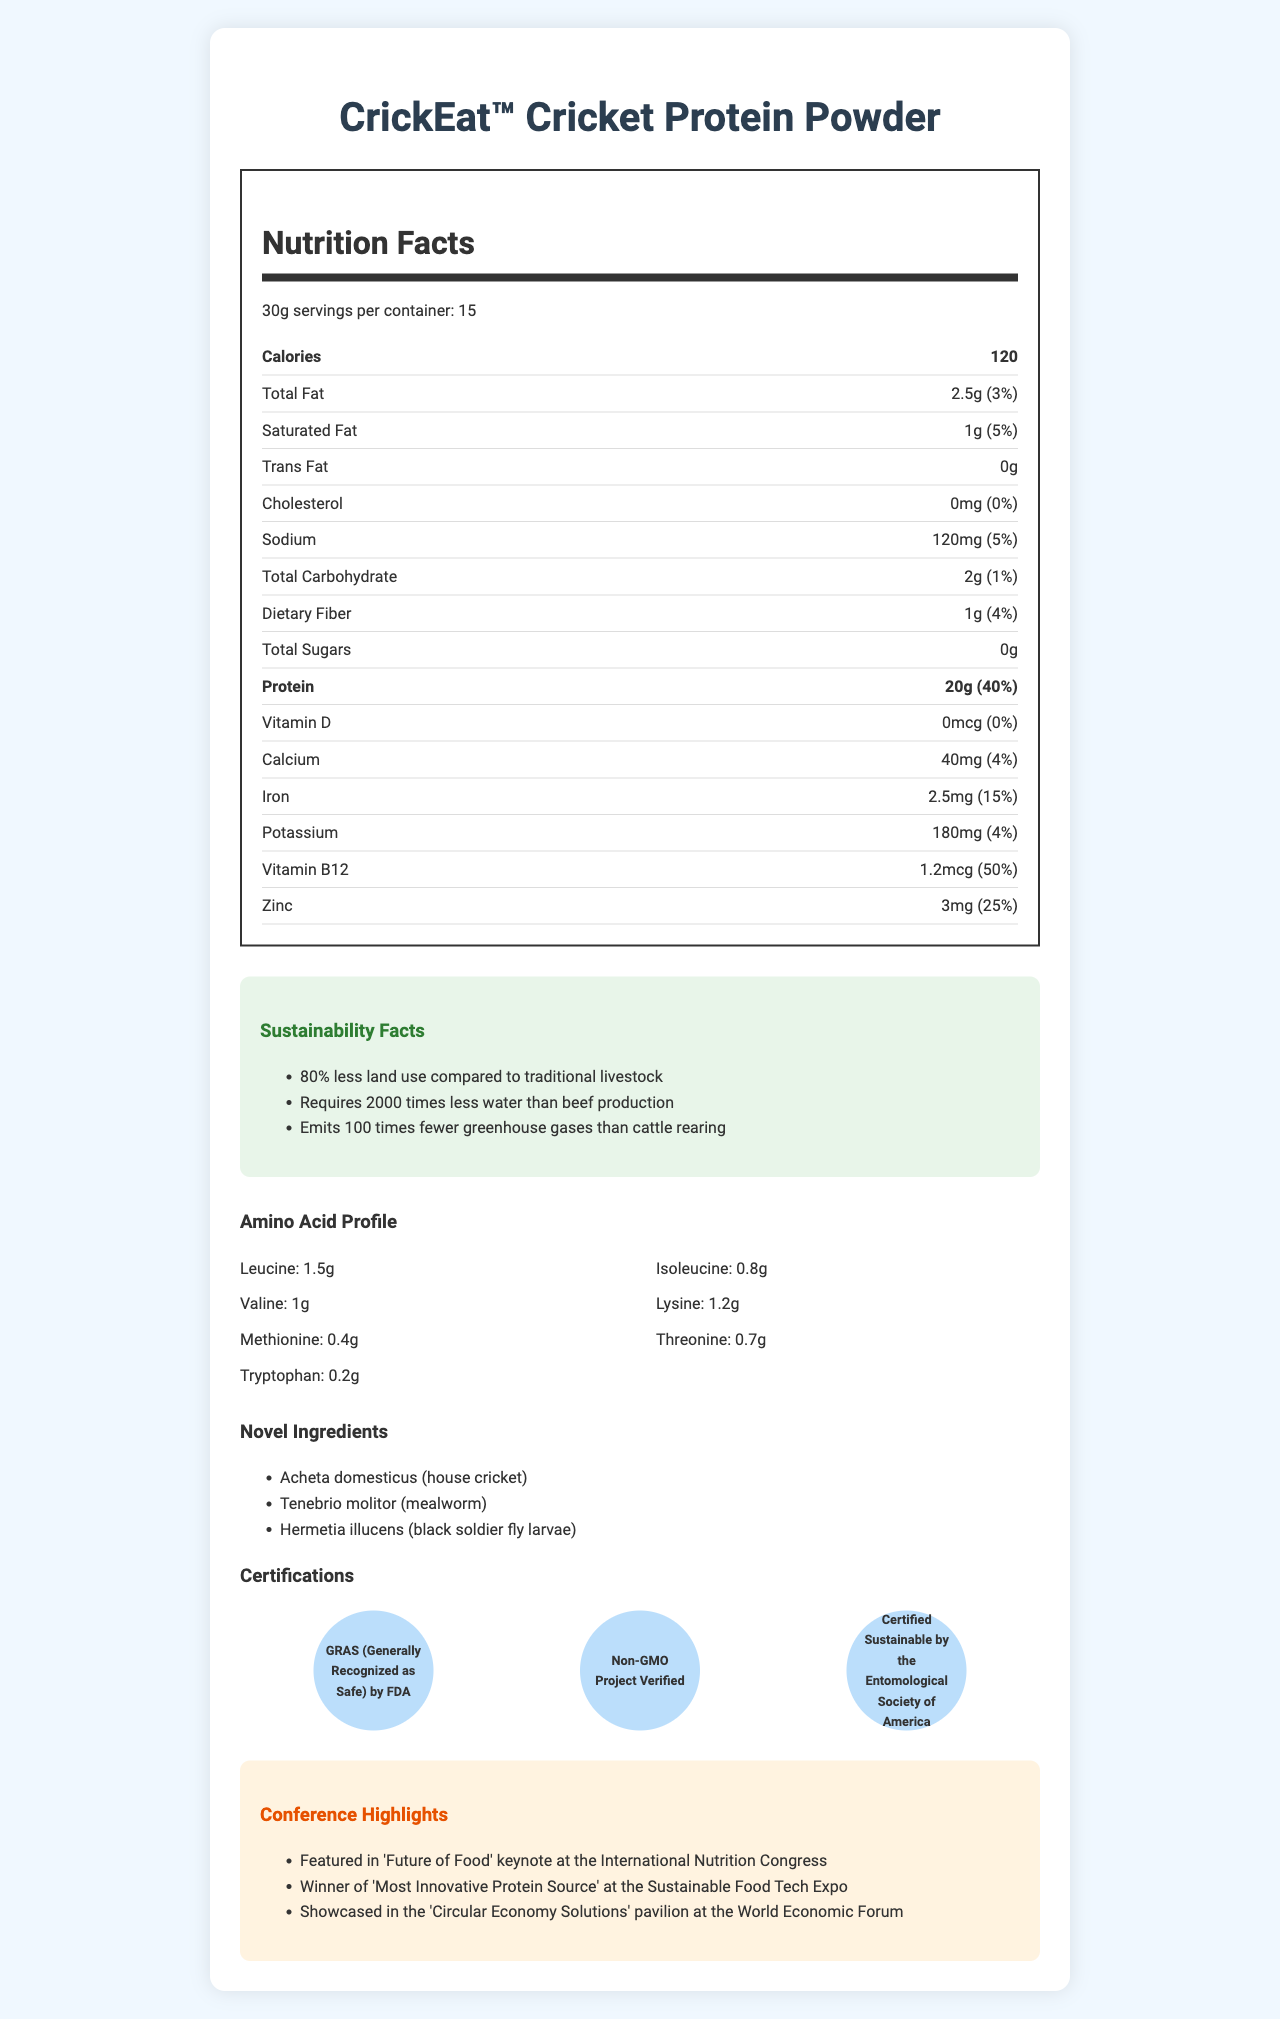what is the serving size of CrickEat™ Cricket Protein Powder? The serving size is mentioned as "30g" in the nutrition label section.
Answer: 30g how many servings are there per container? It states "servings per container: 15" in the nutrition facts.
Answer: 15 how much protein is in one serving? Under the nutrition facts, it mentions "Protein: 20g".
Answer: 20g what percentage of the daily value of iron does one serving provide? It lists iron at "2.5mg (15%)" on the nutrition label.
Answer: 15% what are the novel ingredients in CrickEat™ Cricket Protein Powder? The novel ingredients are listed under the "Novel Ingredients" section.
Answer: Acheta domesticus (house cricket), Tenebrio molitor (mealworm), Hermetia illucens (black soldier fly larvae) how much potassium is in one serving of the product? Potassium is mentioned as "180mg (4%)" on the nutrition label.
Answer: 180mg how much Vitamin B12 is provided per serving? The nutrition label lists Vitamin B12 as "1.2mcg (50%)".
Answer: 1.2mcg how much total carbohydrate is in one serving? Total Carbohydrate is listed as "2g (1%)" on the nutrition label.
Answer: 2g which of the following is not a certification mentioned for CrickEat™ Cricket Protein Powder? A. FDA GRAS B. Non-GMO Project Verified C. Certified Organic D. Certified Sustainable by the Entomological Society of America The certifications listed include GRAS, Non-GMO Project Verified, and Certified Sustainable but not "Certified Organic."
Answer: C. Certified Organic how much trans fat does CrickEat™ Cricket Protein Powder contain? The nutrition facts mention "Trans Fat: 0g".
Answer: 0g which conference featured CrickEat™ in the 'Future of Food' keynote? A. International Nutrition Congress B. Sustainable Food Tech Expo C. World Economic Forum The 'Future of Food' keynote is mentioned as part of the International Nutrition Congress in the conference highlights.
Answer: A. International Nutrition Congress is the product CrickEat™ Cricket Protein Powder Generally Recognized as Safe (GRAS) by the FDA? The certification information mentions "GRAS (Generally Recognized as Safe) by FDA".
Answer: Yes how many calories does one serving of CrickEat™ Cricket Protein Powder contain? The calories are listed as "120" in the nutrition label.
Answer: 120 describe the main idea of the document The document covers various aspects of CrickEat™ Cricket Protein Powder, including its nutrition facts, sustainability benefits, amino acid profile, unique ingredients, certifications, and recognitions at different conferences.
Answer: The document provides a comprehensive nutrient profile of CrickEat™ Cricket Protein Powder, highlighting its nutritional content, sustainability facts, amino acid profile, novel ingredients, certifications, and conference highlights. what is the daily value percentage of dietary fiber per serving? Dietary Fiber is listed as "1g (4%)" in the nutrition label.
Answer: 4% what is the amount of leucine in the amino acid profile? The amino acid profile lists leucine as "1.5g".
Answer: 1.5g can we determine how much zinc is provided in each serving? Zinc is listed as "3mg (25%)" on the nutrition label.
Answer: Yes how many grams of dietary fiber are present in one serving? The nutrition label indicates "Dietary Fiber: 1g (4%)".
Answer: 1g what are the sustainability benefits of CrickEat™ Cricket Protein Powder? The document lists the sustainability facts under the "Sustainability Facts" section.
Answer: 80% less land use compared to traditional livestock, requires 2000 times less water than beef production, emits 100 times fewer greenhouse gases than cattle rearing what amino acid has the smallest amount per serving? The amino acid profile lists tryptophan as "0.2g", which is the smallest amount listed.
Answer: Tryptophan what is the cholesterol content per serving? The nutrition facts state "Cholesterol: 0mg (0%)".
Answer: 0mg 